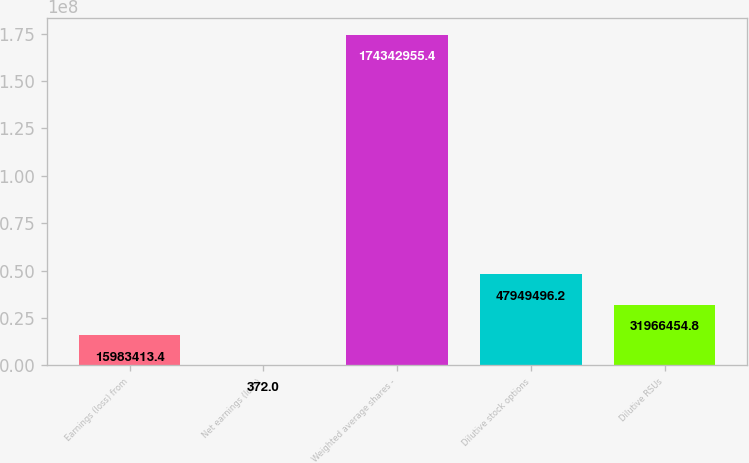Convert chart. <chart><loc_0><loc_0><loc_500><loc_500><bar_chart><fcel>Earnings (loss) from<fcel>Net earnings (loss)<fcel>Weighted average shares -<fcel>Dilutive stock options<fcel>Dilutive RSUs<nl><fcel>1.59834e+07<fcel>372<fcel>1.74343e+08<fcel>4.79495e+07<fcel>3.19665e+07<nl></chart> 